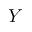<formula> <loc_0><loc_0><loc_500><loc_500>Y</formula> 